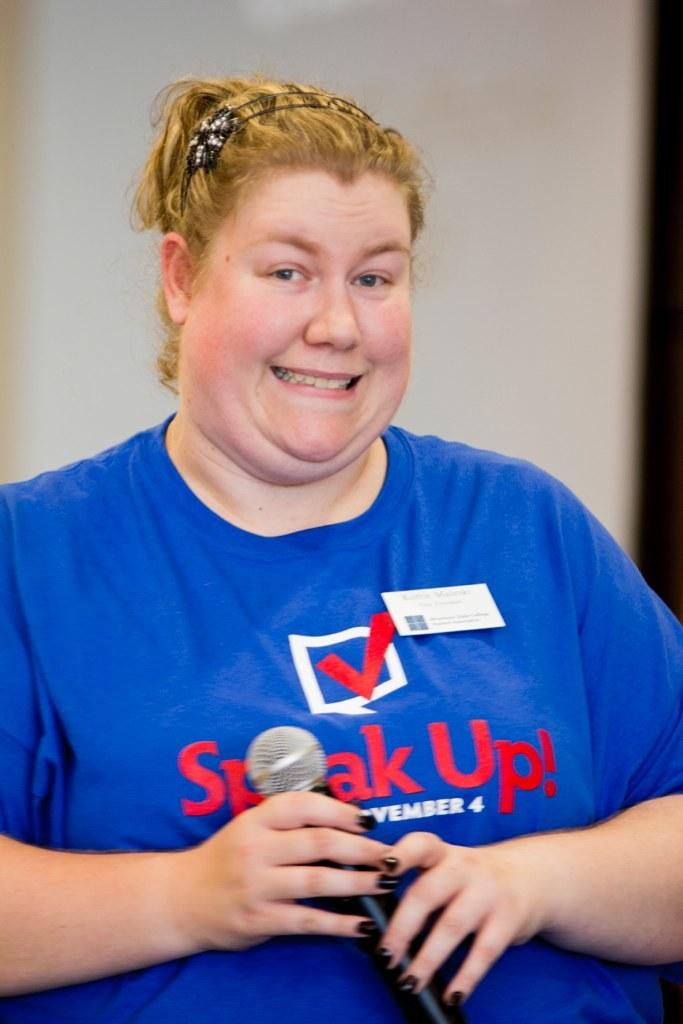Who is the main subject in the image? There is a lady in the image. What is the lady wearing? The lady is wearing a blue t-shirt. What is the lady doing in the image? The lady is standing and holding a mic in her hands. What is the lady's facial expression in the image? The lady is smiling. What type of locket can be seen around the lady's neck in the image? There is no locket visible around the lady's neck in the image. How many cattle are present in the image? There are no cattle present in the image. 